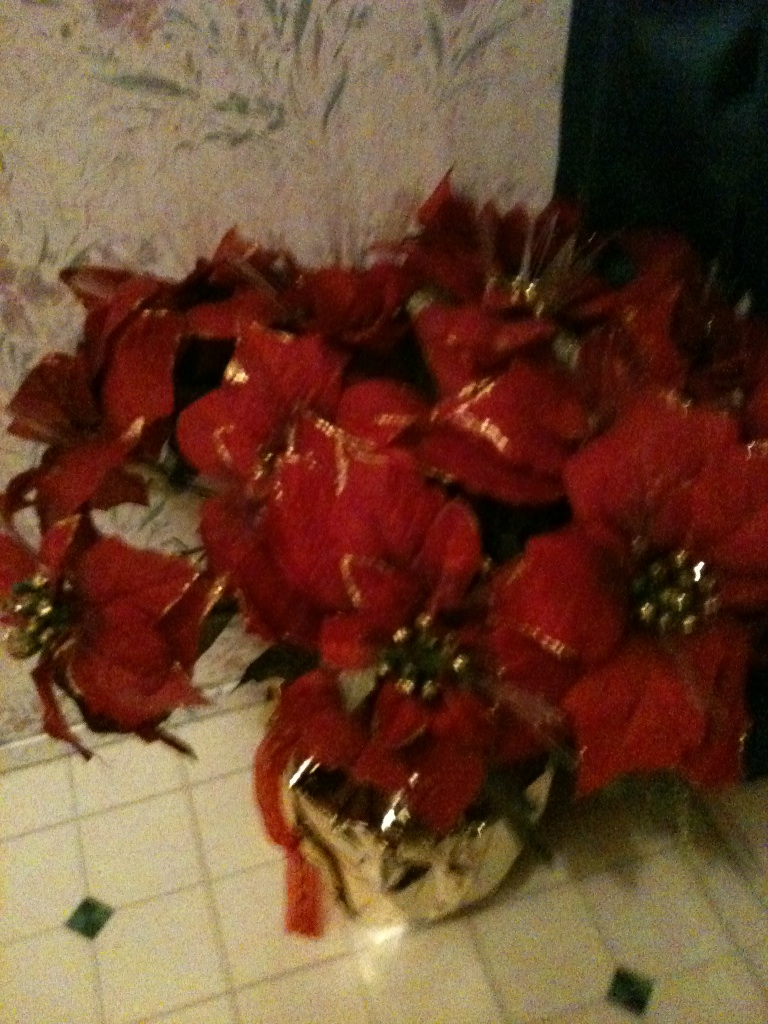What is this item? The item in the image appears to be a bouquet of red poinsettia flowers, often used as a festive decoration during the holiday season. The flowers are arranged in a golden pot, enhancing their vibrant appearance. 